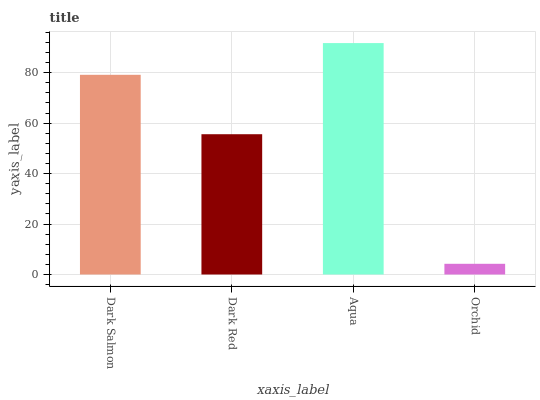Is Orchid the minimum?
Answer yes or no. Yes. Is Aqua the maximum?
Answer yes or no. Yes. Is Dark Red the minimum?
Answer yes or no. No. Is Dark Red the maximum?
Answer yes or no. No. Is Dark Salmon greater than Dark Red?
Answer yes or no. Yes. Is Dark Red less than Dark Salmon?
Answer yes or no. Yes. Is Dark Red greater than Dark Salmon?
Answer yes or no. No. Is Dark Salmon less than Dark Red?
Answer yes or no. No. Is Dark Salmon the high median?
Answer yes or no. Yes. Is Dark Red the low median?
Answer yes or no. Yes. Is Aqua the high median?
Answer yes or no. No. Is Aqua the low median?
Answer yes or no. No. 